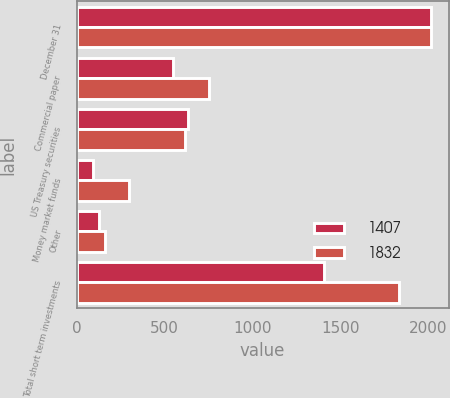Convert chart to OTSL. <chart><loc_0><loc_0><loc_500><loc_500><stacked_bar_chart><ecel><fcel>December 31<fcel>Commercial paper<fcel>US Treasury securities<fcel>Money market funds<fcel>Other<fcel>Total short term investments<nl><fcel>1407<fcel>2013<fcel>549<fcel>636<fcel>94<fcel>128<fcel>1407<nl><fcel>1832<fcel>2012<fcel>751<fcel>617<fcel>301<fcel>163<fcel>1832<nl></chart> 